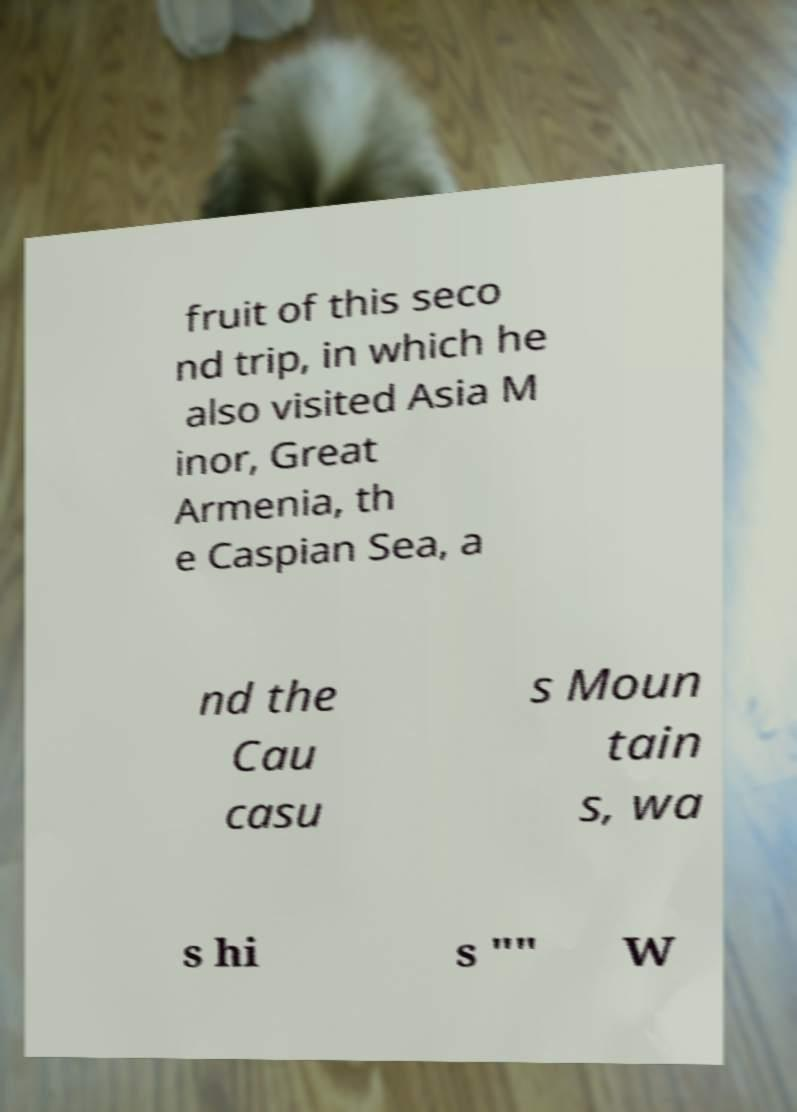Can you read and provide the text displayed in the image?This photo seems to have some interesting text. Can you extract and type it out for me? fruit of this seco nd trip, in which he also visited Asia M inor, Great Armenia, th e Caspian Sea, a nd the Cau casu s Moun tain s, wa s hi s "" W 